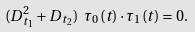<formula> <loc_0><loc_0><loc_500><loc_500>( D _ { t _ { 1 } } ^ { 2 } + D _ { t _ { 2 } } ) \ \tau _ { 0 } ( t ) \cdot \tau _ { 1 } ( t ) = 0 .</formula> 